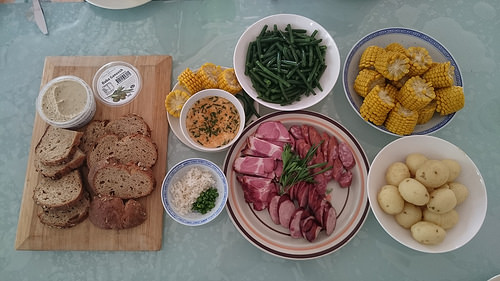<image>
Is the green beans on the plate? No. The green beans is not positioned on the plate. They may be near each other, but the green beans is not supported by or resting on top of the plate. 